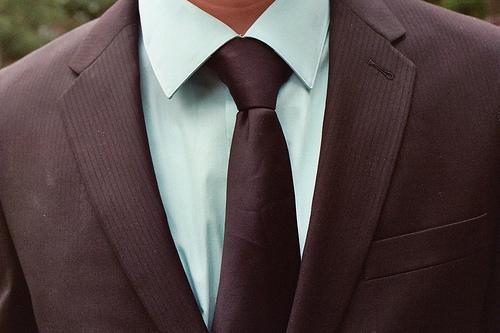How many ties are shown?
Give a very brief answer. 1. How many pieces of clothing are shown?
Give a very brief answer. 3. 